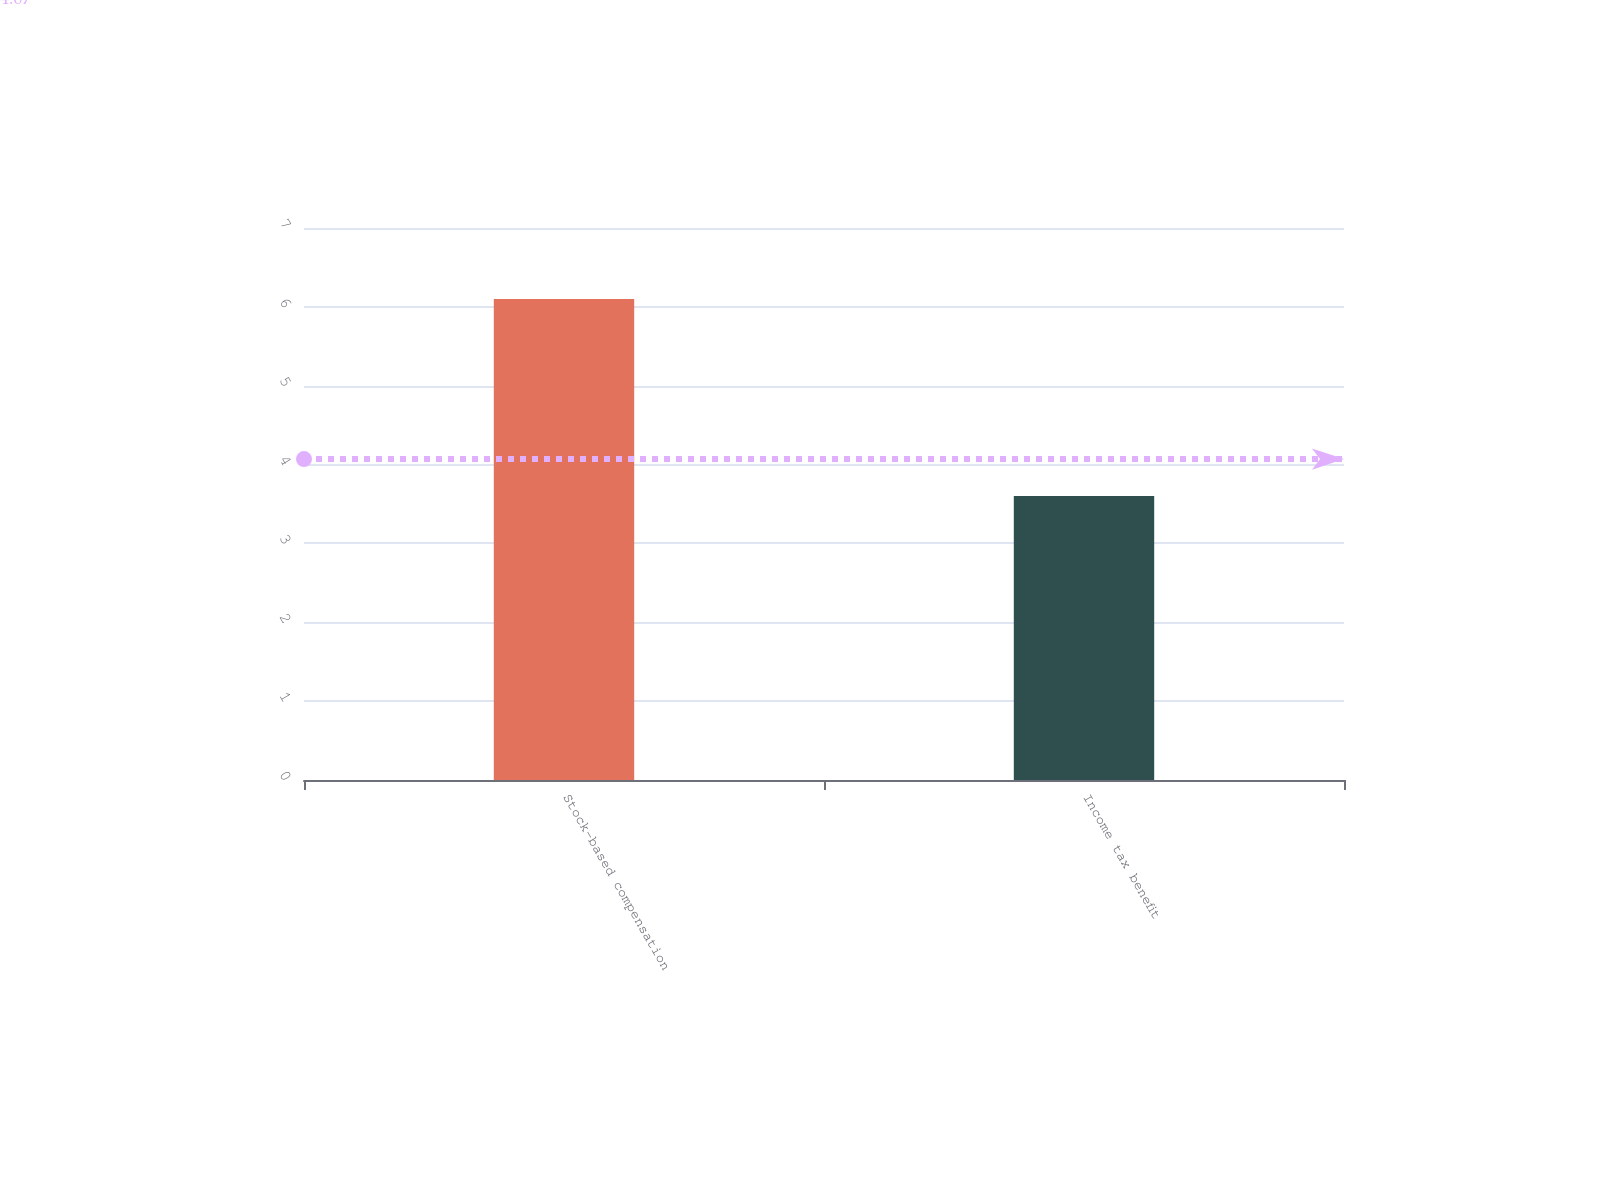Convert chart. <chart><loc_0><loc_0><loc_500><loc_500><bar_chart><fcel>Stock-based compensation<fcel>Income tax benefit<nl><fcel>6.1<fcel>3.6<nl></chart> 